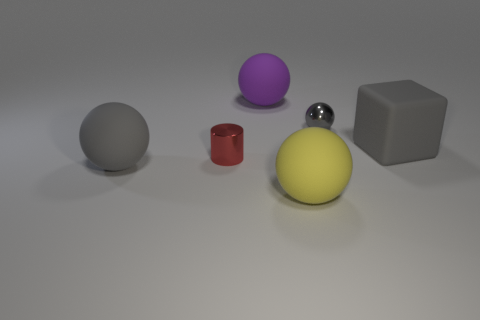The yellow ball has what size?
Offer a terse response. Large. How many big matte objects are behind the sphere in front of the gray matte thing to the left of the purple ball?
Provide a succinct answer. 3. There is a big gray object behind the big matte sphere that is left of the purple rubber object; what is its shape?
Offer a very short reply. Cube. What size is the purple thing that is the same shape as the yellow object?
Offer a very short reply. Large. There is a tiny metallic object that is behind the rubber block; what color is it?
Provide a succinct answer. Gray. There is a gray sphere to the right of the big matte ball that is on the left side of the small metal thing that is in front of the metallic sphere; what is its material?
Keep it short and to the point. Metal. There is a gray matte thing on the right side of the gray ball that is in front of the gray metallic thing; how big is it?
Your answer should be very brief. Large. The other shiny object that is the same shape as the yellow object is what color?
Offer a terse response. Gray. How many tiny metallic objects are the same color as the cube?
Offer a terse response. 1. Is the matte block the same size as the gray metal sphere?
Ensure brevity in your answer.  No. 